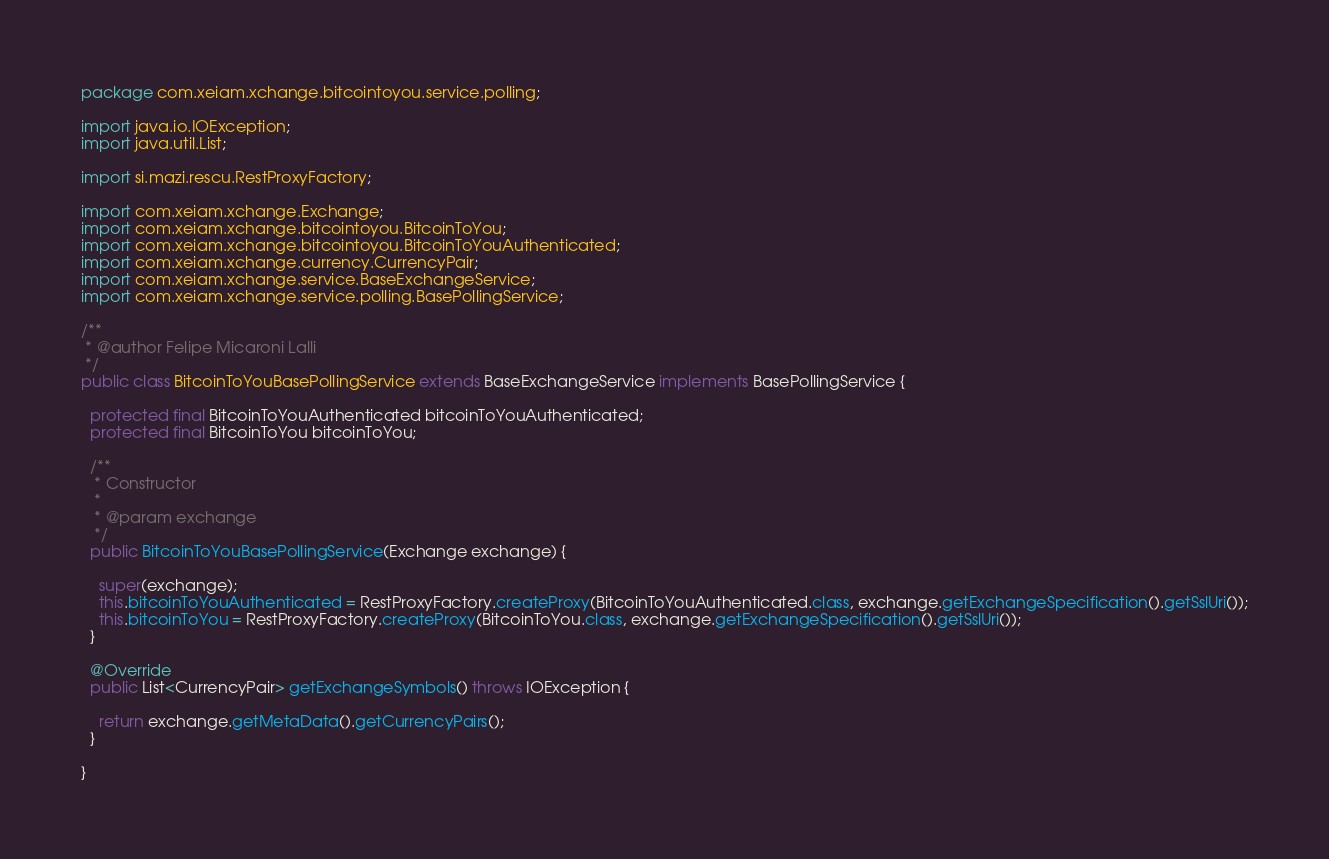<code> <loc_0><loc_0><loc_500><loc_500><_Java_>package com.xeiam.xchange.bitcointoyou.service.polling;

import java.io.IOException;
import java.util.List;

import si.mazi.rescu.RestProxyFactory;

import com.xeiam.xchange.Exchange;
import com.xeiam.xchange.bitcointoyou.BitcoinToYou;
import com.xeiam.xchange.bitcointoyou.BitcoinToYouAuthenticated;
import com.xeiam.xchange.currency.CurrencyPair;
import com.xeiam.xchange.service.BaseExchangeService;
import com.xeiam.xchange.service.polling.BasePollingService;

/**
 * @author Felipe Micaroni Lalli
 */
public class BitcoinToYouBasePollingService extends BaseExchangeService implements BasePollingService {

  protected final BitcoinToYouAuthenticated bitcoinToYouAuthenticated;
  protected final BitcoinToYou bitcoinToYou;

  /**
   * Constructor
   *
   * @param exchange
   */
  public BitcoinToYouBasePollingService(Exchange exchange) {

    super(exchange);
    this.bitcoinToYouAuthenticated = RestProxyFactory.createProxy(BitcoinToYouAuthenticated.class, exchange.getExchangeSpecification().getSslUri());
    this.bitcoinToYou = RestProxyFactory.createProxy(BitcoinToYou.class, exchange.getExchangeSpecification().getSslUri());
  }

  @Override
  public List<CurrencyPair> getExchangeSymbols() throws IOException {

    return exchange.getMetaData().getCurrencyPairs();
  }

}
</code> 